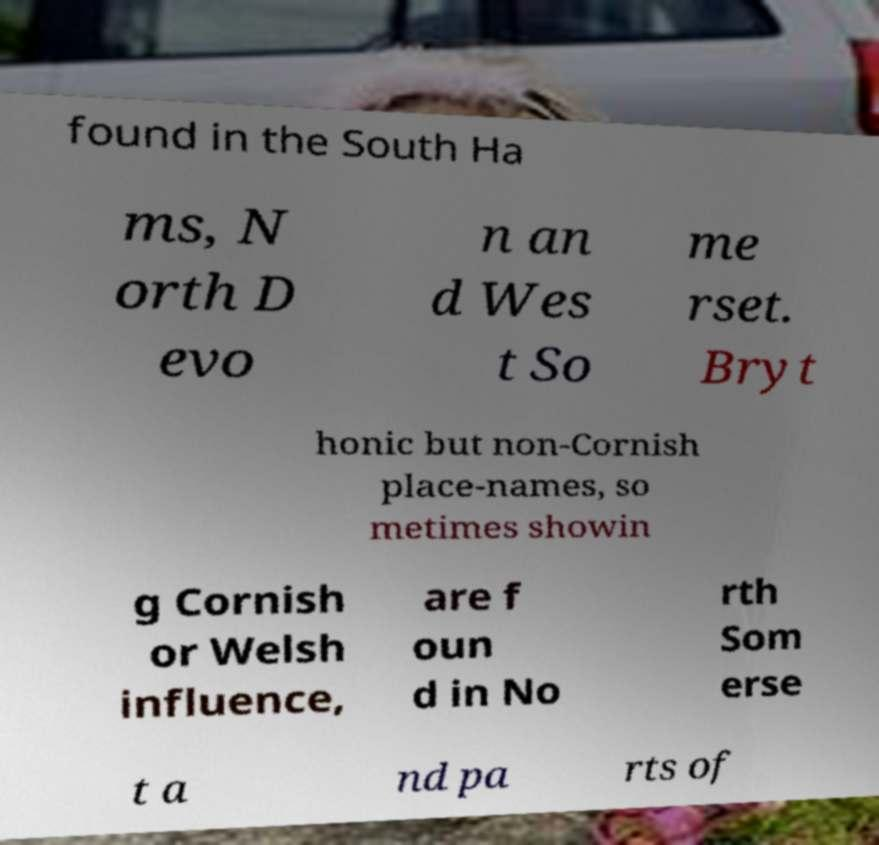Please identify and transcribe the text found in this image. found in the South Ha ms, N orth D evo n an d Wes t So me rset. Bryt honic but non-Cornish place-names, so metimes showin g Cornish or Welsh influence, are f oun d in No rth Som erse t a nd pa rts of 